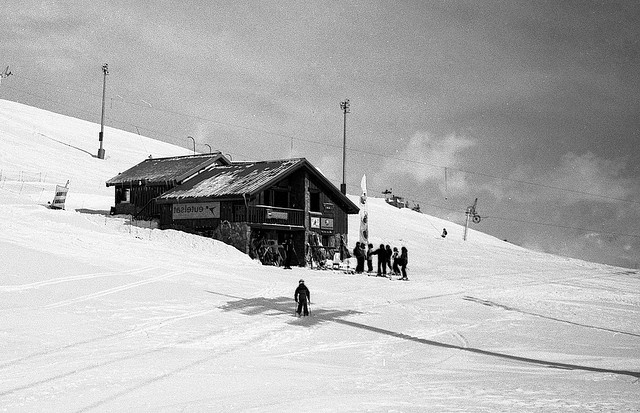Describe the objects in this image and their specific colors. I can see people in darkgray, black, gray, and lightgray tones, people in darkgray, black, gray, and lightgray tones, people in darkgray, black, gray, and lightgray tones, people in darkgray, black, gray, and lightgray tones, and people in darkgray, black, gray, and lightgray tones in this image. 